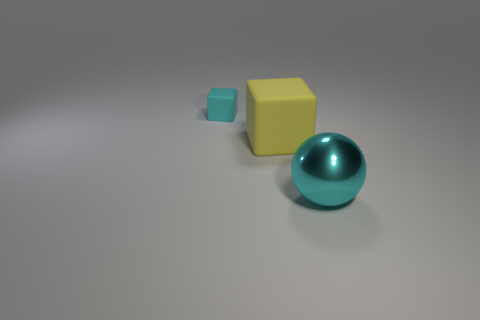Are there any other things that are made of the same material as the ball? The image shows a ball that appears to be made of a reflective material, likely a plastic or polished metal. The cubes in the image also seem to have a smooth surface, which suggests they could be made of a similar type of material. However, without more information, it's not possible to confirm if they are composed of the exact same substance. 